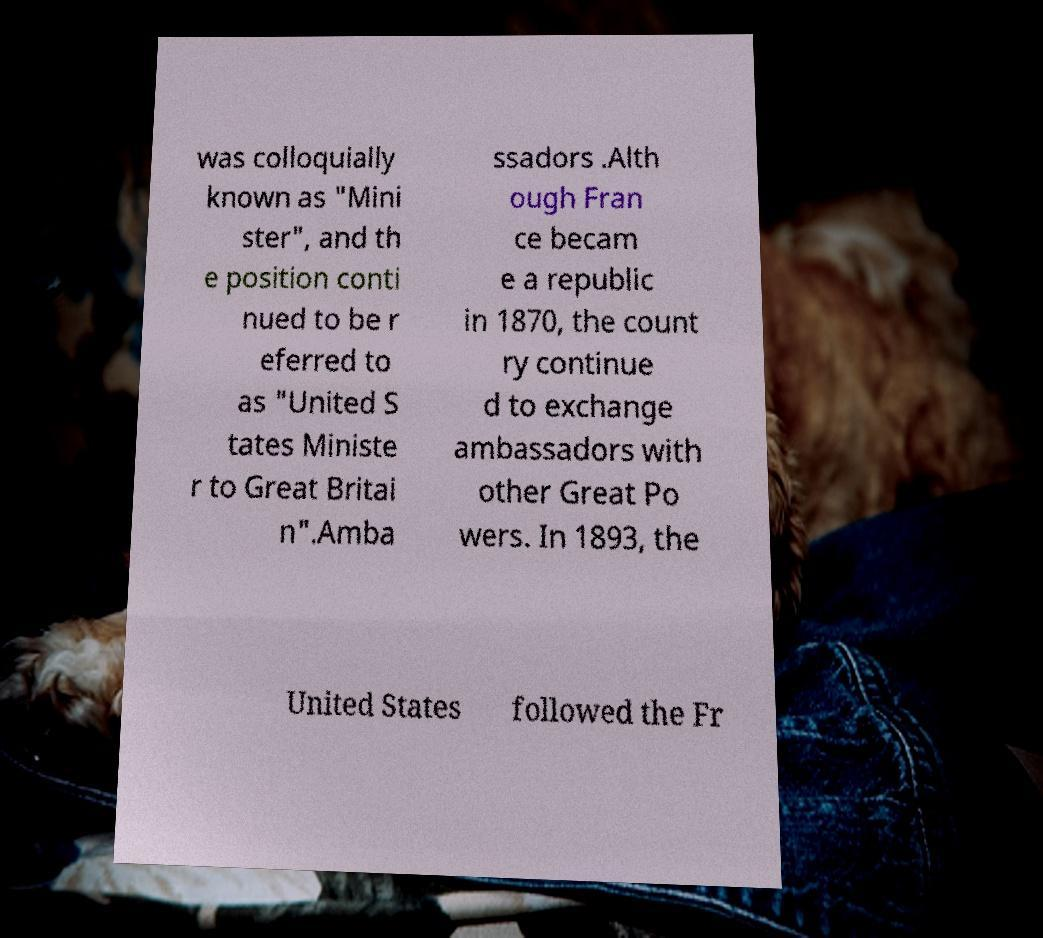Please read and relay the text visible in this image. What does it say? was colloquially known as "Mini ster", and th e position conti nued to be r eferred to as "United S tates Ministe r to Great Britai n".Amba ssadors .Alth ough Fran ce becam e a republic in 1870, the count ry continue d to exchange ambassadors with other Great Po wers. In 1893, the United States followed the Fr 